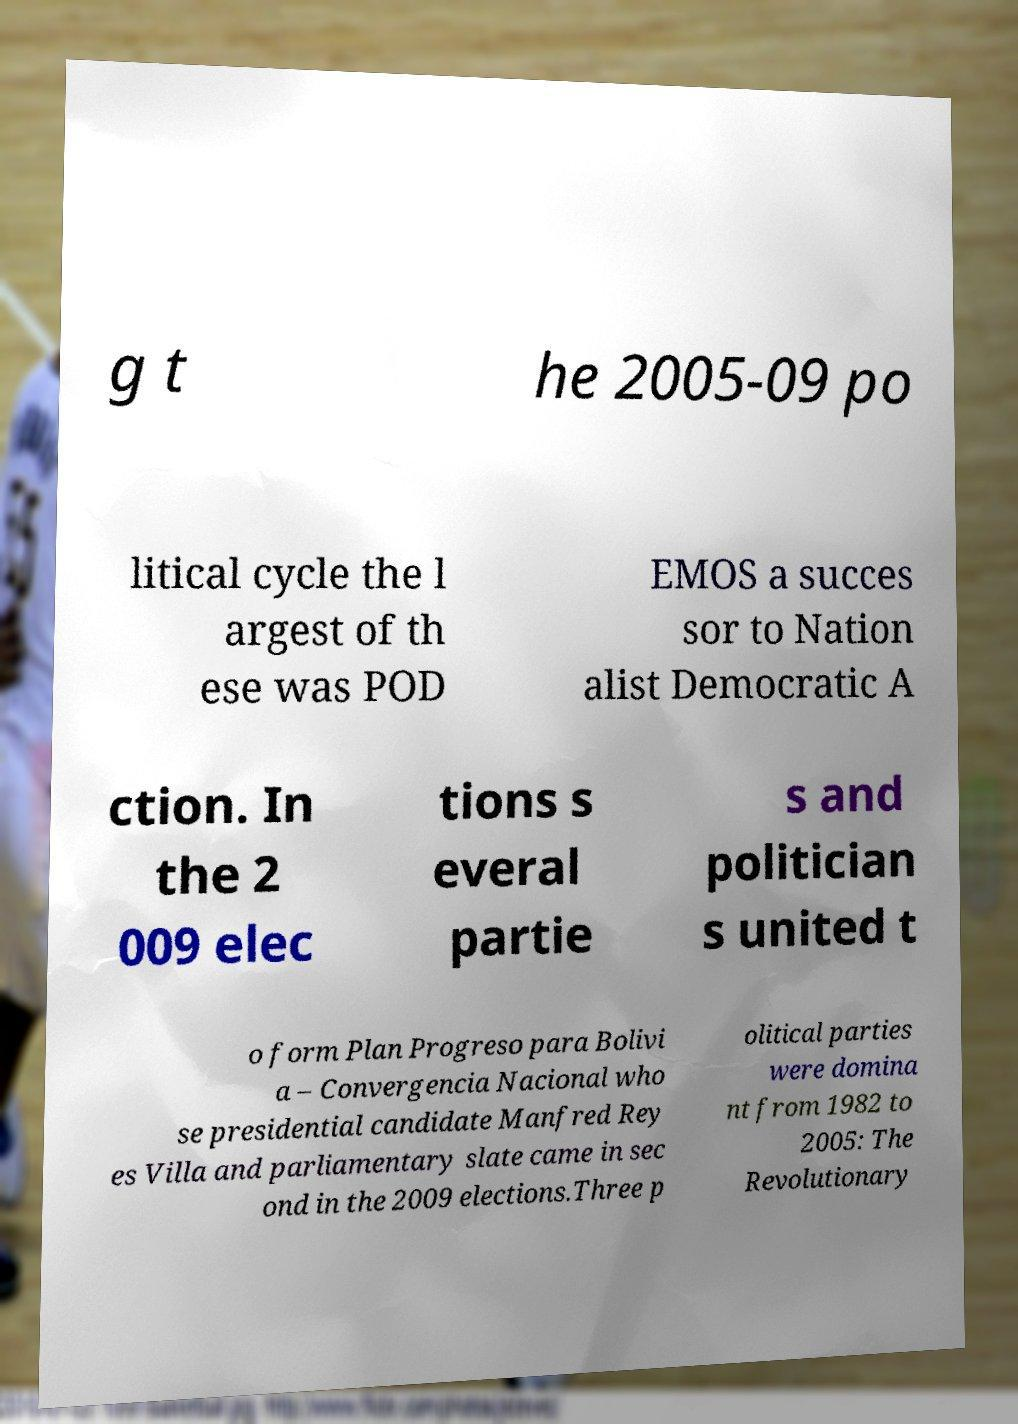Could you assist in decoding the text presented in this image and type it out clearly? g t he 2005-09 po litical cycle the l argest of th ese was POD EMOS a succes sor to Nation alist Democratic A ction. In the 2 009 elec tions s everal partie s and politician s united t o form Plan Progreso para Bolivi a – Convergencia Nacional who se presidential candidate Manfred Rey es Villa and parliamentary slate came in sec ond in the 2009 elections.Three p olitical parties were domina nt from 1982 to 2005: The Revolutionary 